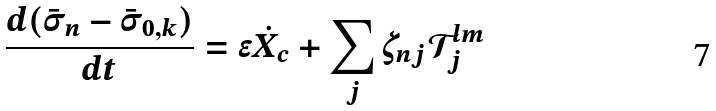<formula> <loc_0><loc_0><loc_500><loc_500>\frac { d ( \bar { \sigma } _ { n } - \bar { \sigma } _ { 0 , k } ) } { d t } = \epsilon \dot { X } _ { c } + \sum _ { j } \zeta _ { n j } \mathcal { T } _ { j } ^ { l m }</formula> 